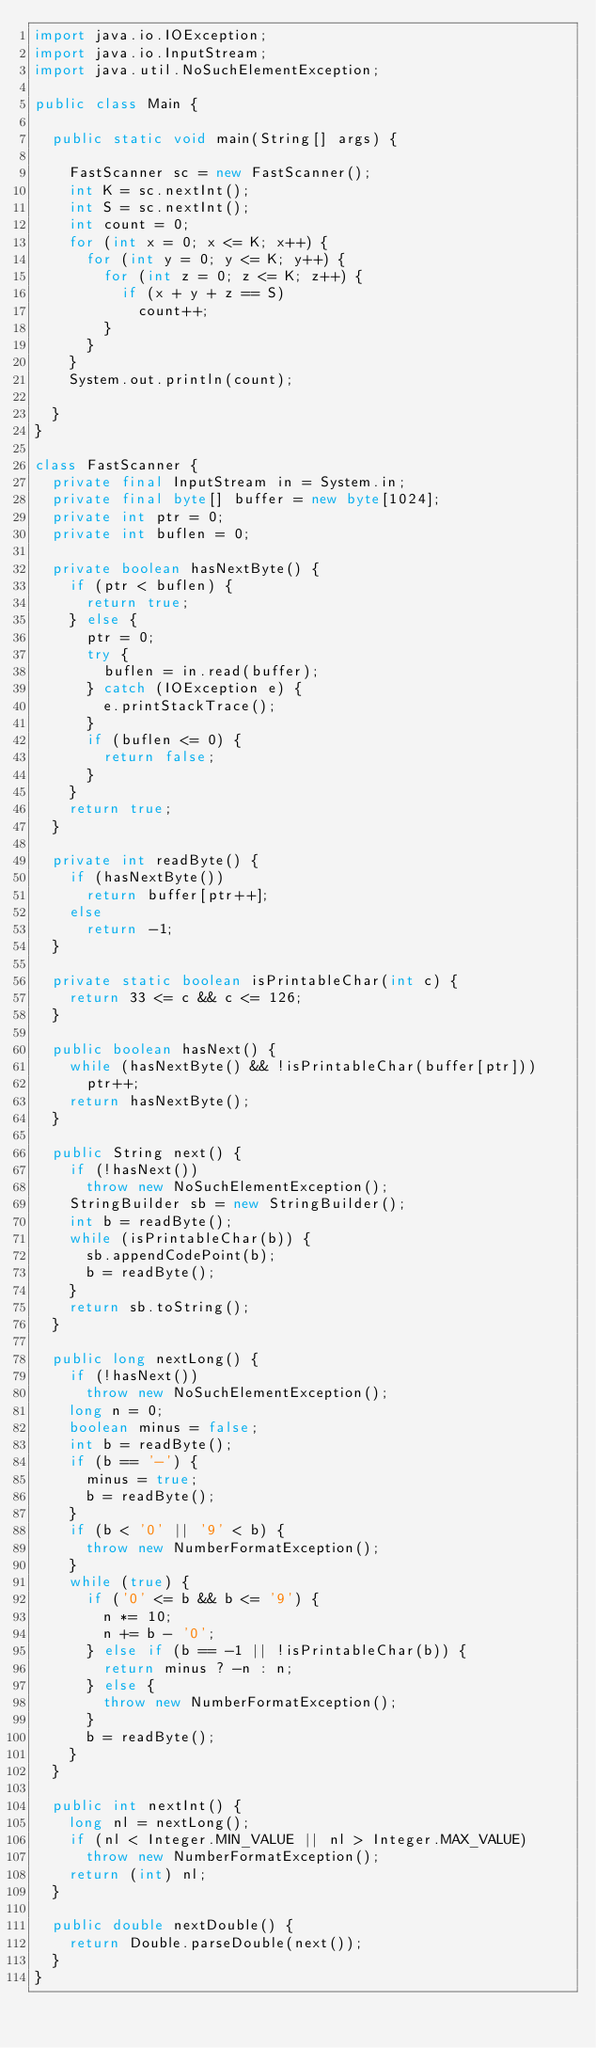<code> <loc_0><loc_0><loc_500><loc_500><_Java_>import java.io.IOException;
import java.io.InputStream;
import java.util.NoSuchElementException;

public class Main {

	public static void main(String[] args) {

		FastScanner sc = new FastScanner();
		int K = sc.nextInt();
		int S = sc.nextInt();
		int count = 0;
		for (int x = 0; x <= K; x++) {
			for (int y = 0; y <= K; y++) {
				for (int z = 0; z <= K; z++) {
					if (x + y + z == S)
						count++;
				}
			}
		}
		System.out.println(count);

	}
}

class FastScanner {
	private final InputStream in = System.in;
	private final byte[] buffer = new byte[1024];
	private int ptr = 0;
	private int buflen = 0;

	private boolean hasNextByte() {
		if (ptr < buflen) {
			return true;
		} else {
			ptr = 0;
			try {
				buflen = in.read(buffer);
			} catch (IOException e) {
				e.printStackTrace();
			}
			if (buflen <= 0) {
				return false;
			}
		}
		return true;
	}

	private int readByte() {
		if (hasNextByte())
			return buffer[ptr++];
		else
			return -1;
	}

	private static boolean isPrintableChar(int c) {
		return 33 <= c && c <= 126;
	}

	public boolean hasNext() {
		while (hasNextByte() && !isPrintableChar(buffer[ptr]))
			ptr++;
		return hasNextByte();
	}

	public String next() {
		if (!hasNext())
			throw new NoSuchElementException();
		StringBuilder sb = new StringBuilder();
		int b = readByte();
		while (isPrintableChar(b)) {
			sb.appendCodePoint(b);
			b = readByte();
		}
		return sb.toString();
	}

	public long nextLong() {
		if (!hasNext())
			throw new NoSuchElementException();
		long n = 0;
		boolean minus = false;
		int b = readByte();
		if (b == '-') {
			minus = true;
			b = readByte();
		}
		if (b < '0' || '9' < b) {
			throw new NumberFormatException();
		}
		while (true) {
			if ('0' <= b && b <= '9') {
				n *= 10;
				n += b - '0';
			} else if (b == -1 || !isPrintableChar(b)) {
				return minus ? -n : n;
			} else {
				throw new NumberFormatException();
			}
			b = readByte();
		}
	}

	public int nextInt() {
		long nl = nextLong();
		if (nl < Integer.MIN_VALUE || nl > Integer.MAX_VALUE)
			throw new NumberFormatException();
		return (int) nl;
	}

	public double nextDouble() {
		return Double.parseDouble(next());
	}
}
</code> 